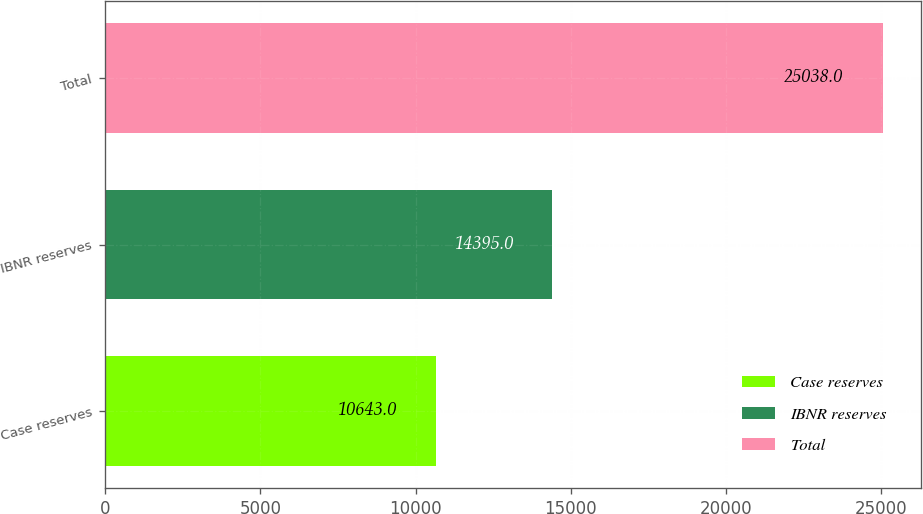Convert chart to OTSL. <chart><loc_0><loc_0><loc_500><loc_500><bar_chart><fcel>Case reserves<fcel>IBNR reserves<fcel>Total<nl><fcel>10643<fcel>14395<fcel>25038<nl></chart> 